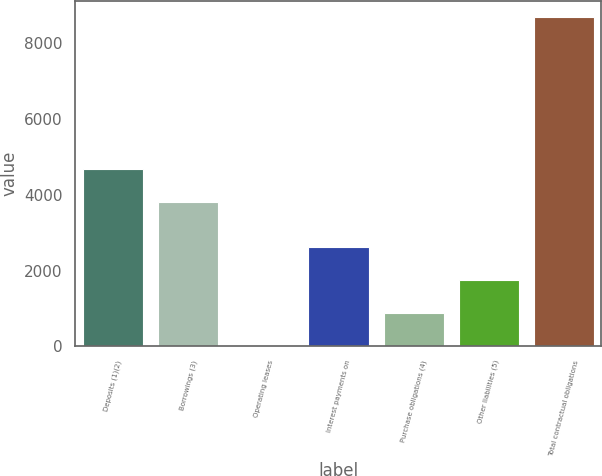Convert chart to OTSL. <chart><loc_0><loc_0><loc_500><loc_500><bar_chart><fcel>Deposits (1)(2)<fcel>Borrowings (3)<fcel>Operating leases<fcel>Interest payments on<fcel>Purchase obligations (4)<fcel>Other liabilities (5)<fcel>Total contractual obligations<nl><fcel>4682.7<fcel>3815<fcel>17<fcel>2620.1<fcel>884.7<fcel>1752.4<fcel>8694<nl></chart> 